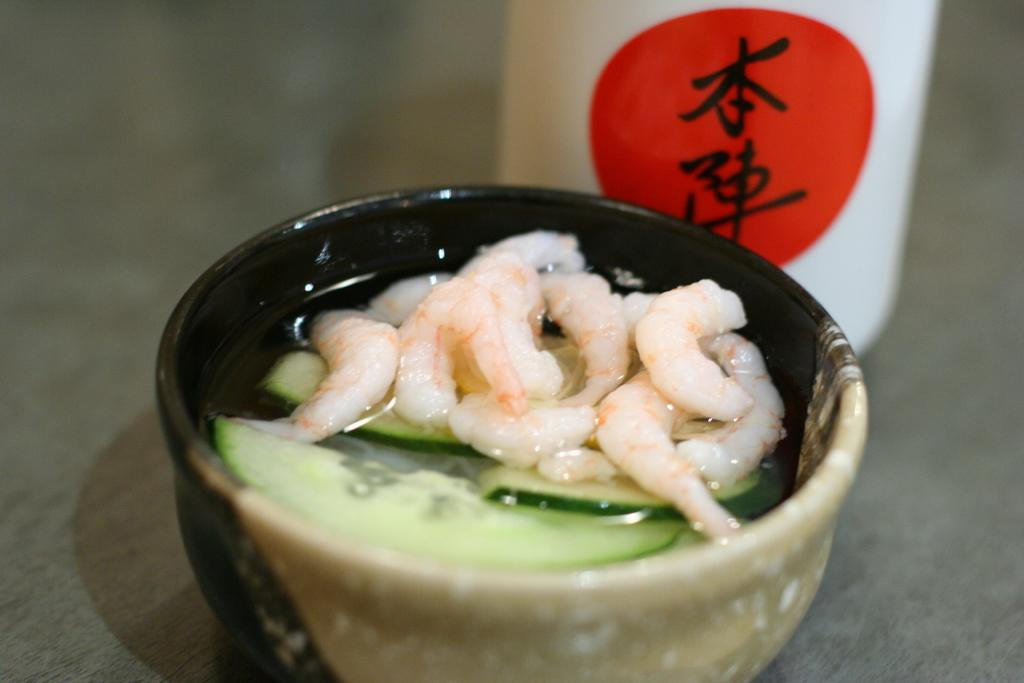What is in the bowl that is visible in the image? There is food in a bowl in the image. Can you describe the object behind the bowl? Unfortunately, the provided facts do not give any information about the object behind the bowl. What type of loaf is being ordered by the team in the image? There is no team or loaf present in the image; it only features a bowl of food and an unidentified object behind it. 